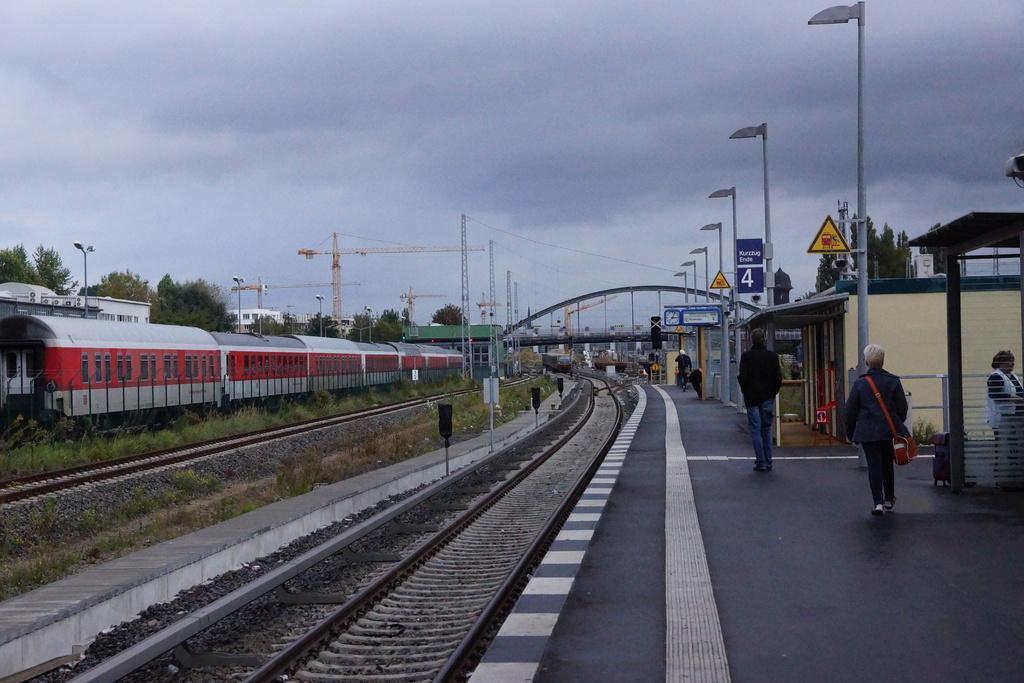Can you describe this image briefly? In the picture I can see railway tracks, poles, trees, people walking on the railway platform, sign boards, towers and some other objects. In the background I can see the sky. 